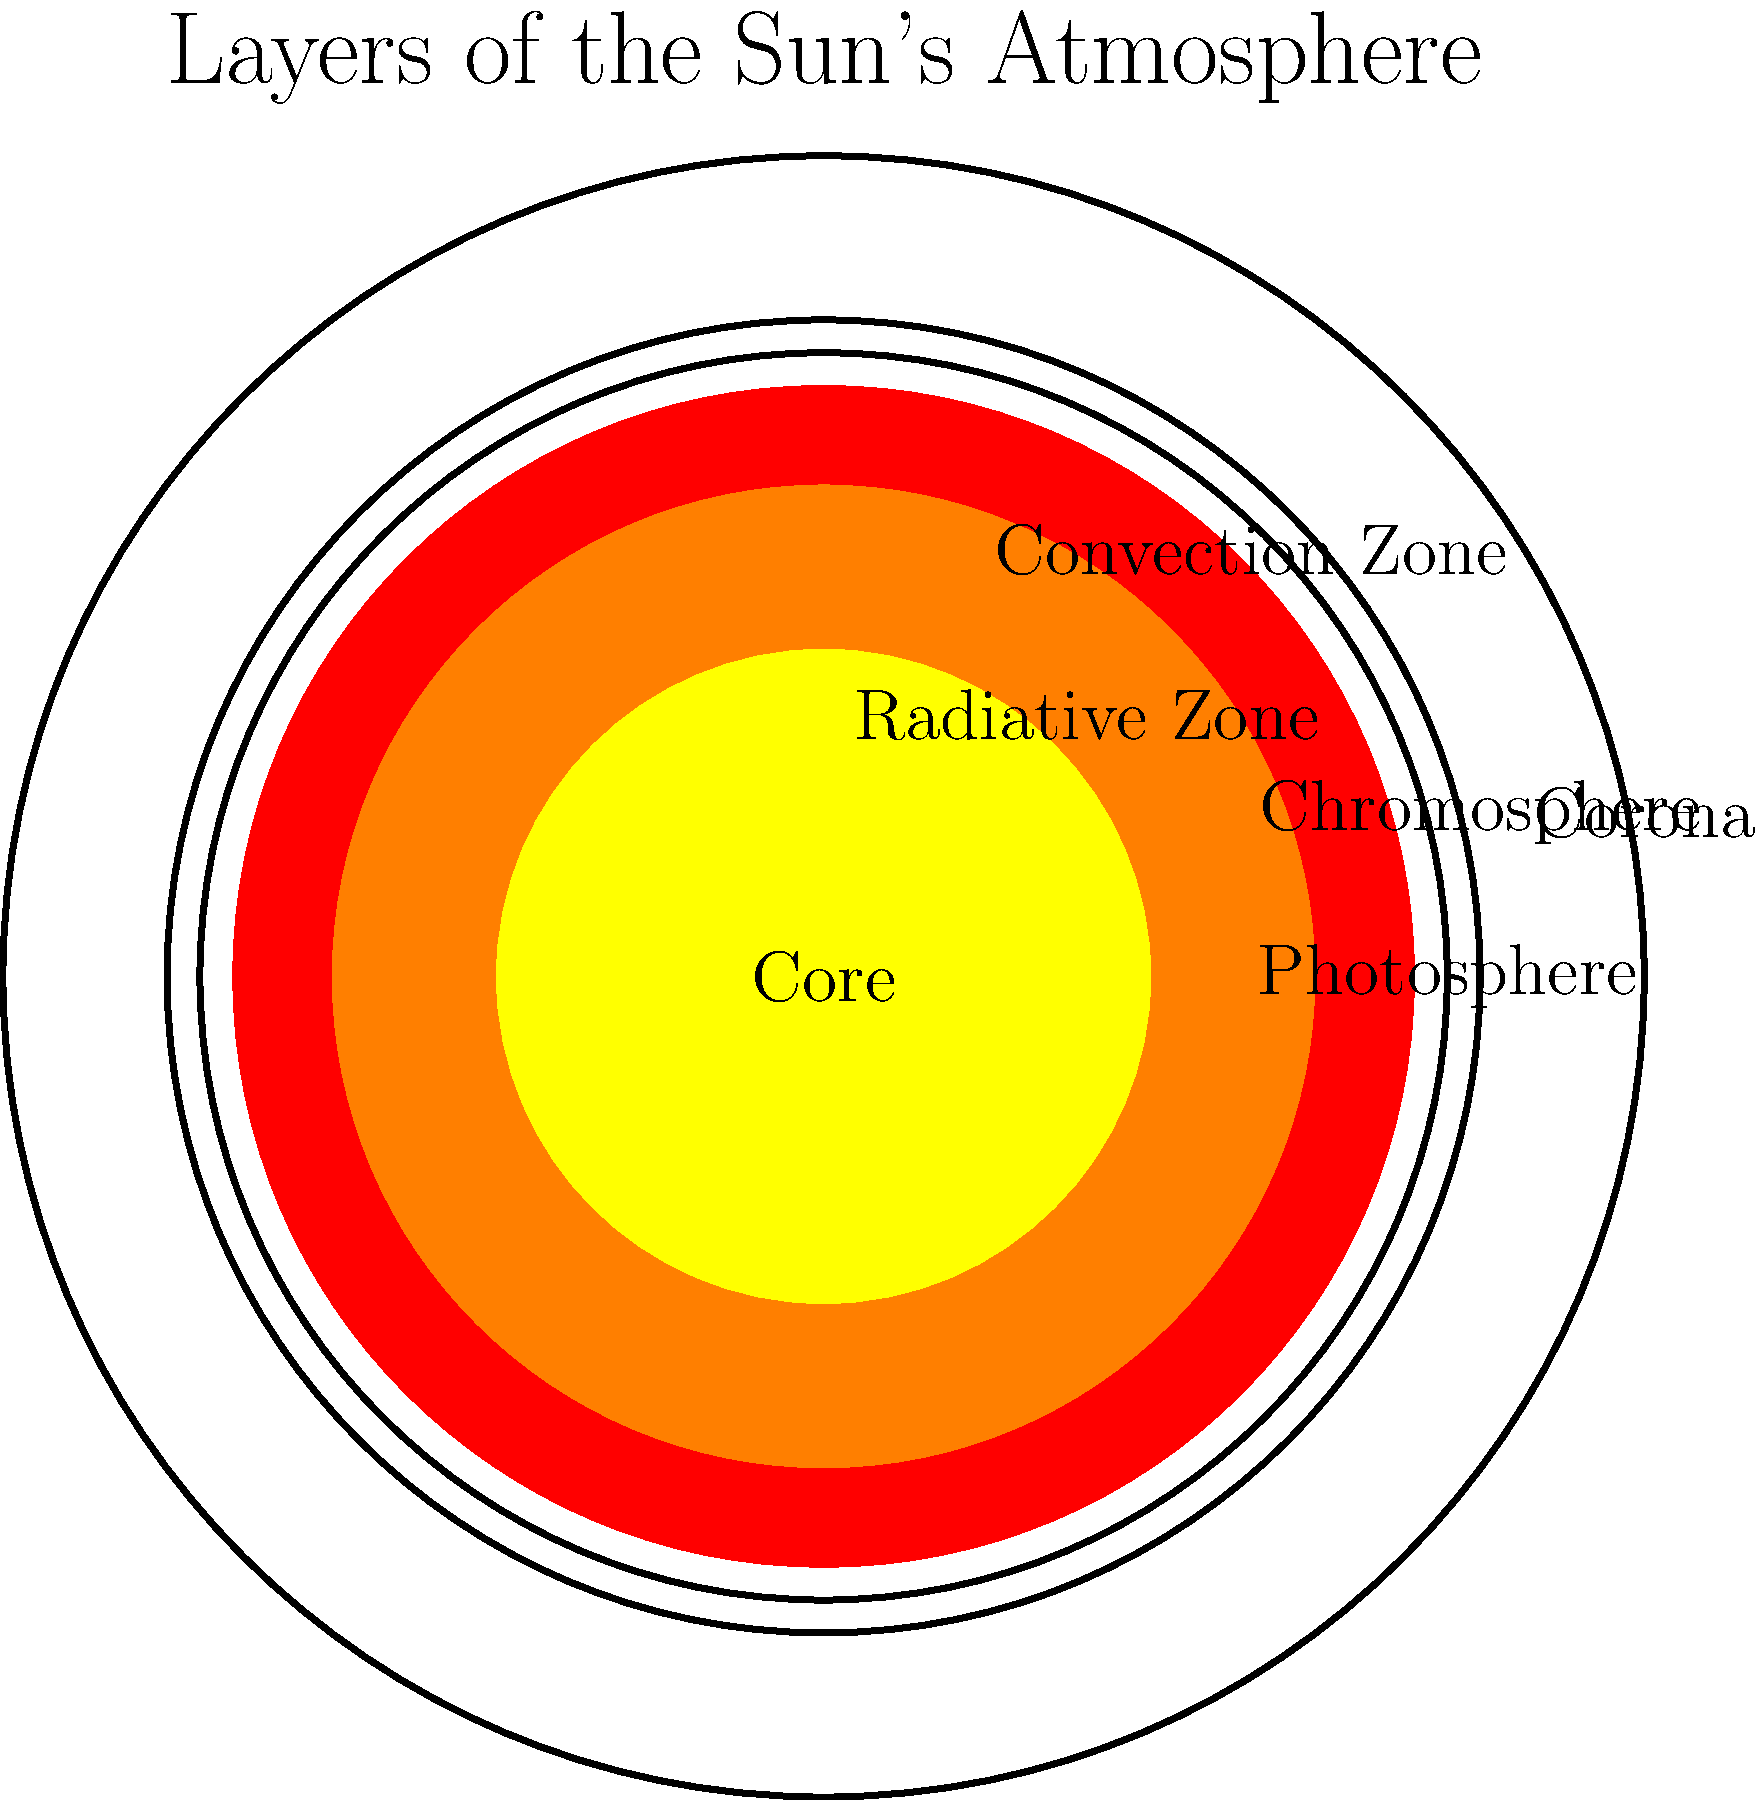Dear friend, could you please help me understand which layer of the Sun's atmosphere is known for its beautiful pink color during a total solar eclipse? Certainly! Let's go through the layers of the Sun's atmosphere step-by-step:

1. The innermost layer is the core, where nuclear fusion occurs.
2. Moving outward, we have the radiative zone, where energy is transferred by radiation.
3. Next is the convection zone, where energy is transferred by convection currents.
4. The visible "surface" of the Sun is called the photosphere.
5. Above the photosphere is the chromosphere. This layer is typically not visible to the naked eye due to the bright light from the photosphere.
6. The outermost layer is the corona, which extends far into space.

During a total solar eclipse, when the Moon blocks the bright light from the photosphere, the chromosphere becomes visible. It appears as a thin, pinkish-red layer around the edge of the Moon's silhouette. This pink color is due to the emission of light from hydrogen atoms in the chromosphere.

So, the layer known for its beautiful pink color during a total solar eclipse is the chromosphere.
Answer: Chromosphere 